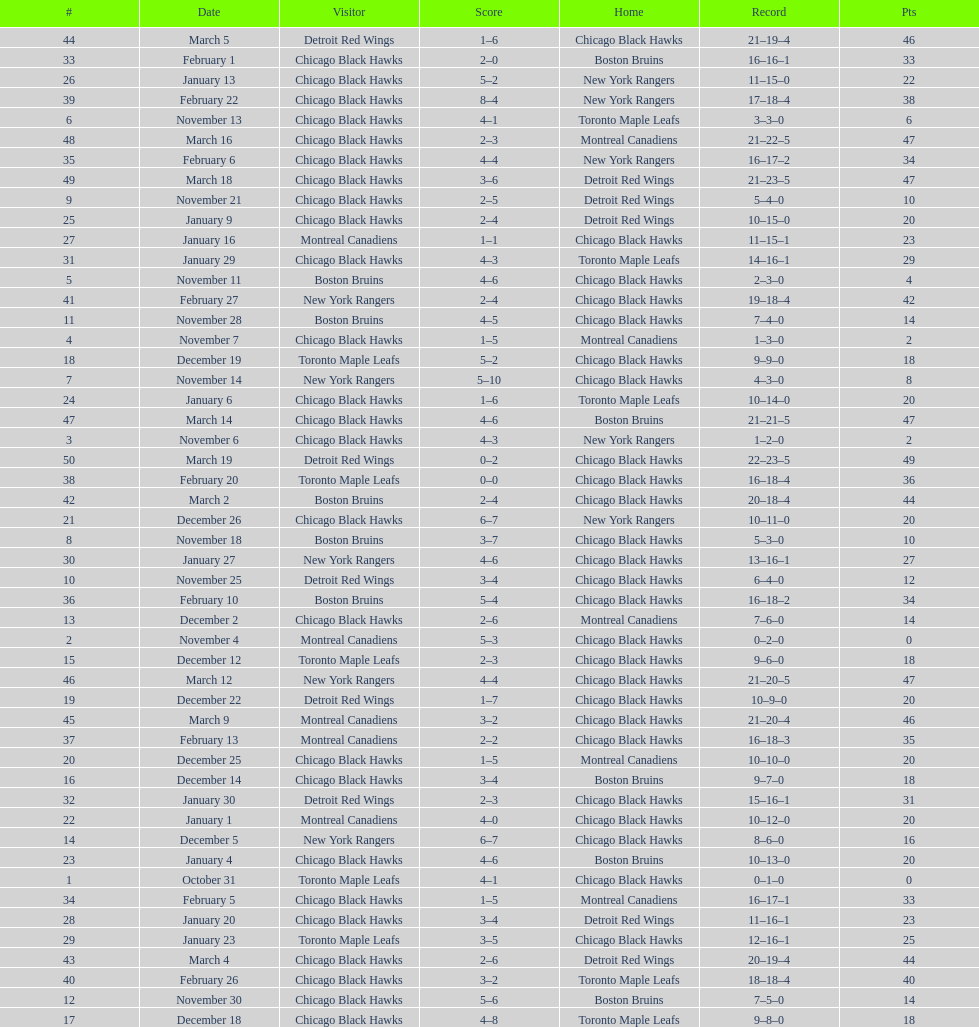What was the total amount of points scored on november 4th? 8. 